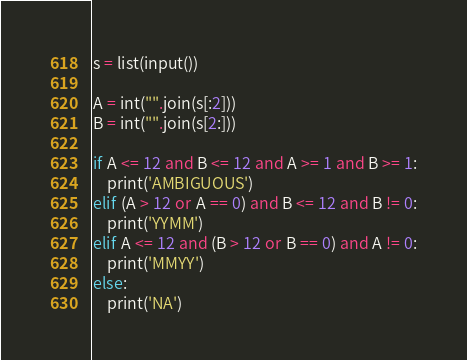Convert code to text. <code><loc_0><loc_0><loc_500><loc_500><_Python_>s = list(input())

A = int("".join(s[:2]))
B = int("".join(s[2:]))

if A <= 12 and B <= 12 and A >= 1 and B >= 1:
    print('AMBIGUOUS')
elif (A > 12 or A == 0) and B <= 12 and B != 0:
    print('YYMM')
elif A <= 12 and (B > 12 or B == 0) and A != 0:
    print('MMYY')
else:
    print('NA')</code> 